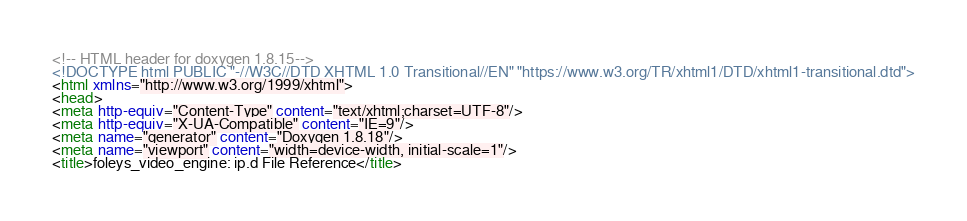<code> <loc_0><loc_0><loc_500><loc_500><_HTML_><!-- HTML header for doxygen 1.8.15-->
<!DOCTYPE html PUBLIC "-//W3C//DTD XHTML 1.0 Transitional//EN" "https://www.w3.org/TR/xhtml1/DTD/xhtml1-transitional.dtd">
<html xmlns="http://www.w3.org/1999/xhtml">
<head>
<meta http-equiv="Content-Type" content="text/xhtml;charset=UTF-8"/>
<meta http-equiv="X-UA-Compatible" content="IE=9"/>
<meta name="generator" content="Doxygen 1.8.18"/>
<meta name="viewport" content="width=device-width, initial-scale=1"/>
<title>foleys_video_engine: ip.d File Reference</title></code> 